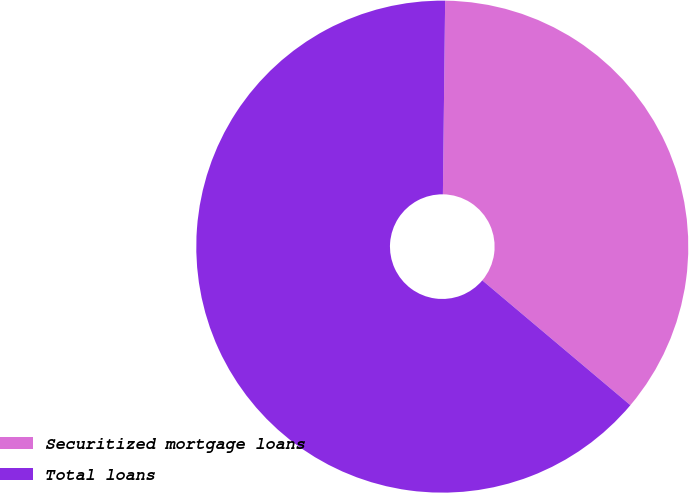<chart> <loc_0><loc_0><loc_500><loc_500><pie_chart><fcel>Securitized mortgage loans<fcel>Total loans<nl><fcel>35.96%<fcel>64.04%<nl></chart> 